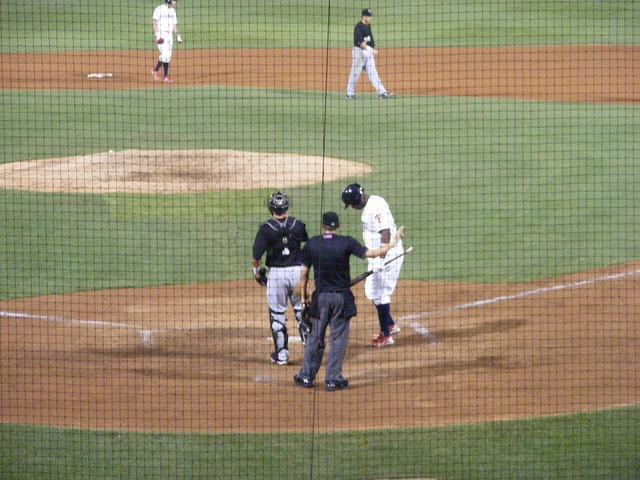Who is wearing the most gear?
Answer the question by selecting the correct answer among the 4 following choices and explain your choice with a short sentence. The answer should be formatted with the following format: `Answer: choice
Rationale: rationale.`
Options: Police officer, fire fighter, clown, catcher. Answer: catcher.
Rationale: It's to protect them from being hurt by the ball. 